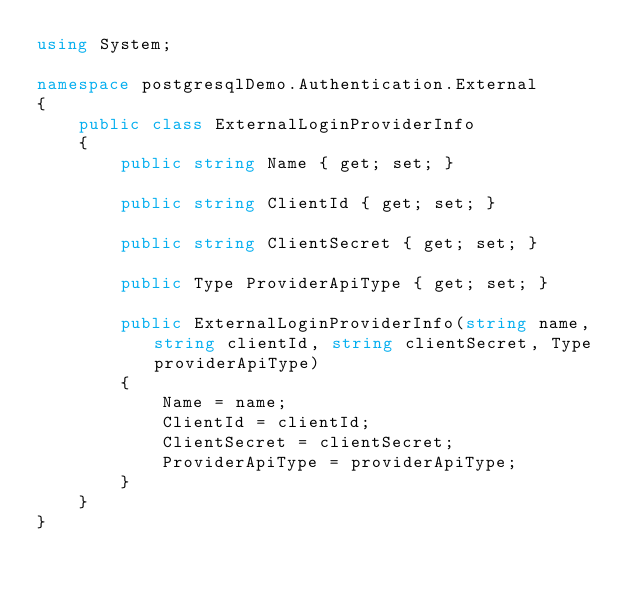Convert code to text. <code><loc_0><loc_0><loc_500><loc_500><_C#_>using System;

namespace postgresqlDemo.Authentication.External
{
    public class ExternalLoginProviderInfo
    {
        public string Name { get; set; }

        public string ClientId { get; set; }

        public string ClientSecret { get; set; }

        public Type ProviderApiType { get; set; }

        public ExternalLoginProviderInfo(string name, string clientId, string clientSecret, Type providerApiType)
        {
            Name = name;
            ClientId = clientId;
            ClientSecret = clientSecret;
            ProviderApiType = providerApiType;
        }
    }
}
</code> 